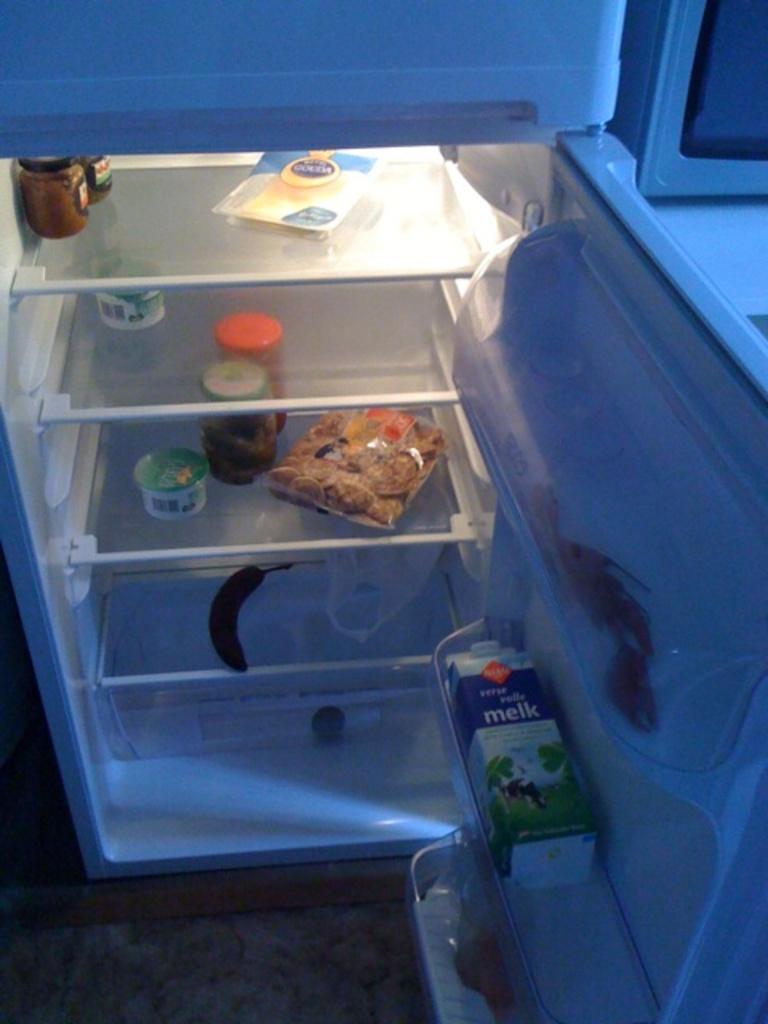What kind of drink is in the carton on the right?
Keep it short and to the point. Melk. Is there milk in the fridge?
Your answer should be very brief. Yes. 